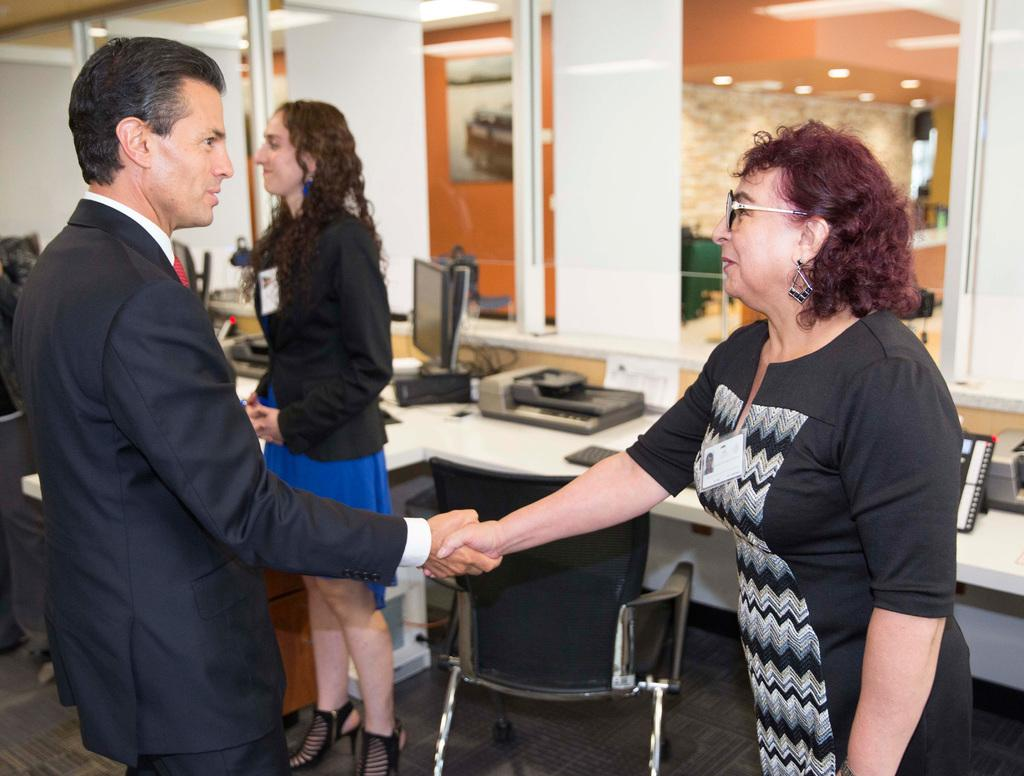How many people are present in the image? There is a man and two women in the image, making a total of three people. What is the man doing in the image? The man is sitting in a chair in the image. What can be seen on the table in the image? There are machines and other things on the table in the image. What is the purpose of the monitor in the image? The purpose of the monitor in the image is not clear from the facts provided, but it is likely being used for displaying information or as a screen for the machines. What is visible in the background of the image? There are lights visible in the background of the image. What type of notebook is the man holding in the image? There is no notebook present in the image. What statement does the duck make in the image? There is no duck present in the image, so it cannot make any statements. 